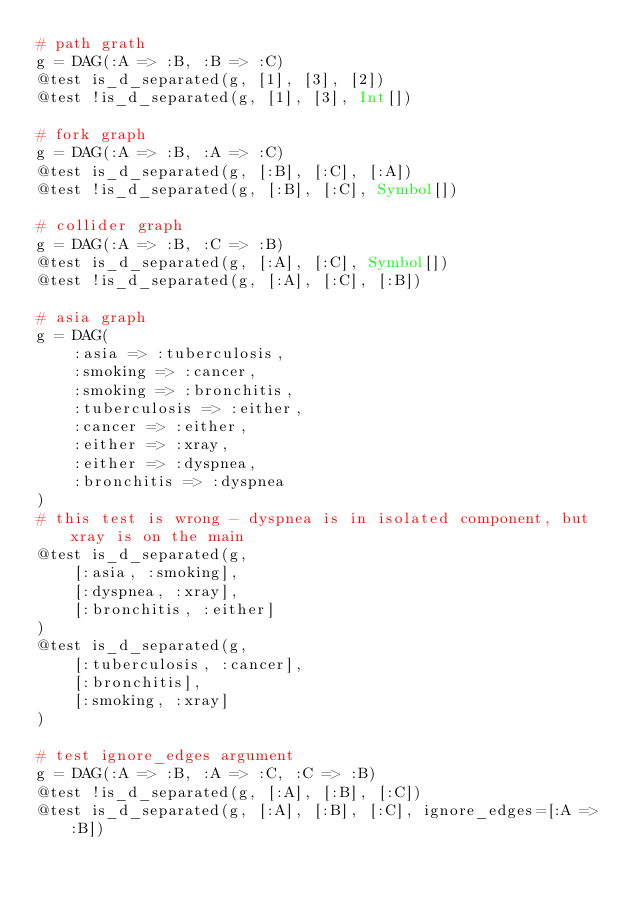Convert code to text. <code><loc_0><loc_0><loc_500><loc_500><_Julia_># path grath
g = DAG(:A => :B, :B => :C)
@test is_d_separated(g, [1], [3], [2])
@test !is_d_separated(g, [1], [3], Int[])

# fork graph
g = DAG(:A => :B, :A => :C)
@test is_d_separated(g, [:B], [:C], [:A])
@test !is_d_separated(g, [:B], [:C], Symbol[])

# collider graph
g = DAG(:A => :B, :C => :B)
@test is_d_separated(g, [:A], [:C], Symbol[])
@test !is_d_separated(g, [:A], [:C], [:B])

# asia graph
g = DAG(
    :asia => :tuberculosis,
    :smoking => :cancer,
    :smoking => :bronchitis,
    :tuberculosis => :either,
    :cancer => :either,
    :either => :xray,
    :either => :dyspnea,
    :bronchitis => :dyspnea
)
# this test is wrong - dyspnea is in isolated component, but xray is on the main
@test is_d_separated(g,
    [:asia, :smoking],
    [:dyspnea, :xray],
    [:bronchitis, :either]
)
@test is_d_separated(g,
    [:tuberculosis, :cancer],
    [:bronchitis],
    [:smoking, :xray]
)

# test ignore_edges argument
g = DAG(:A => :B, :A => :C, :C => :B)
@test !is_d_separated(g, [:A], [:B], [:C])
@test is_d_separated(g, [:A], [:B], [:C], ignore_edges=[:A => :B])
</code> 